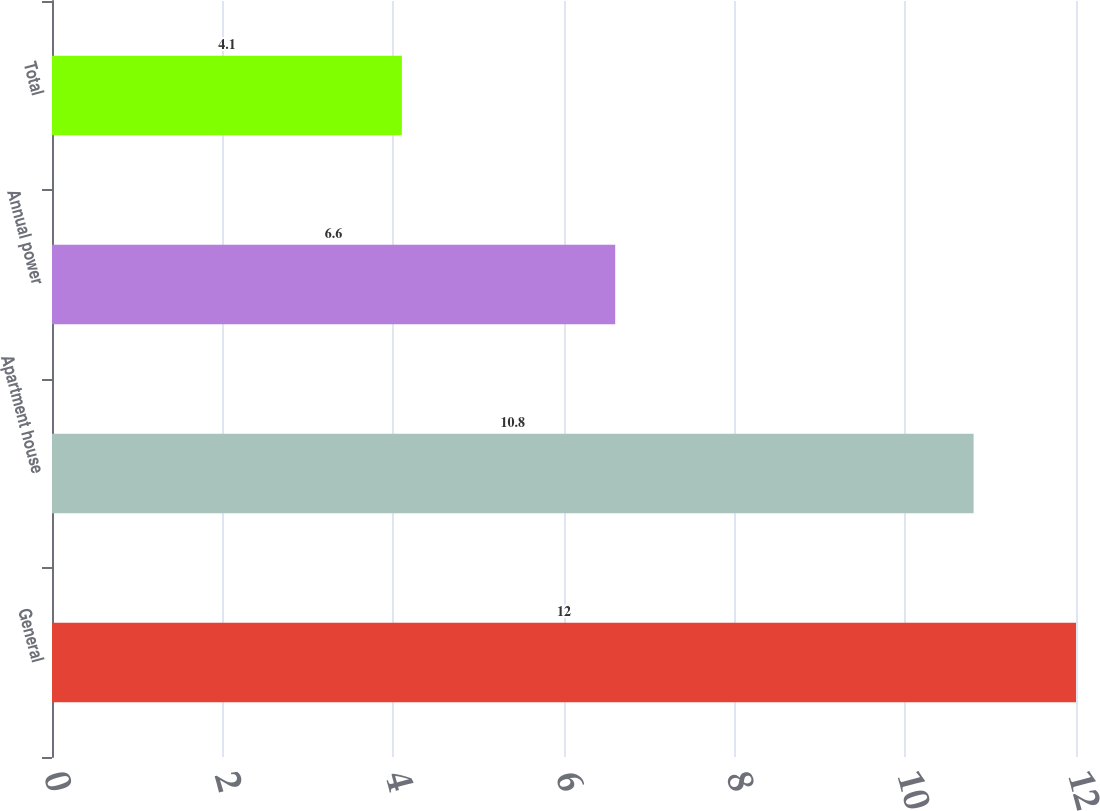Convert chart to OTSL. <chart><loc_0><loc_0><loc_500><loc_500><bar_chart><fcel>General<fcel>Apartment house<fcel>Annual power<fcel>Total<nl><fcel>12<fcel>10.8<fcel>6.6<fcel>4.1<nl></chart> 